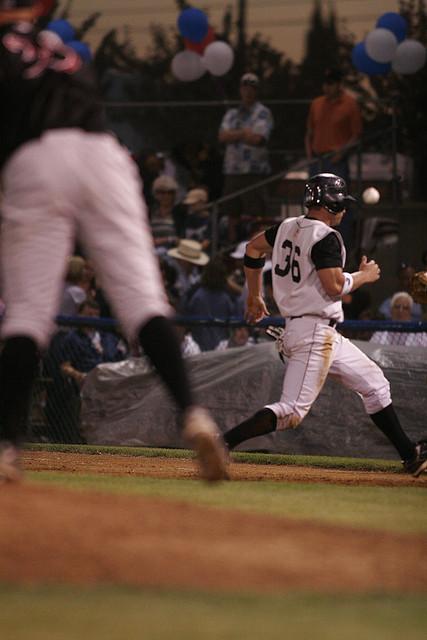Is the baseball in motion?
Give a very brief answer. Yes. Is the ball going to continue going up?
Short answer required. No. What number is on the player's shirt?
Concise answer only. 36. 